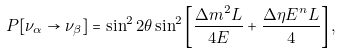<formula> <loc_0><loc_0><loc_500><loc_500>P [ \nu _ { \alpha } \rightarrow \nu _ { \beta } ] = \sin ^ { 2 } 2 \theta \sin ^ { 2 } \left [ \frac { \Delta m ^ { 2 } L } { 4 E } + \frac { \Delta \eta E ^ { n } L } { 4 } \right ] ,</formula> 